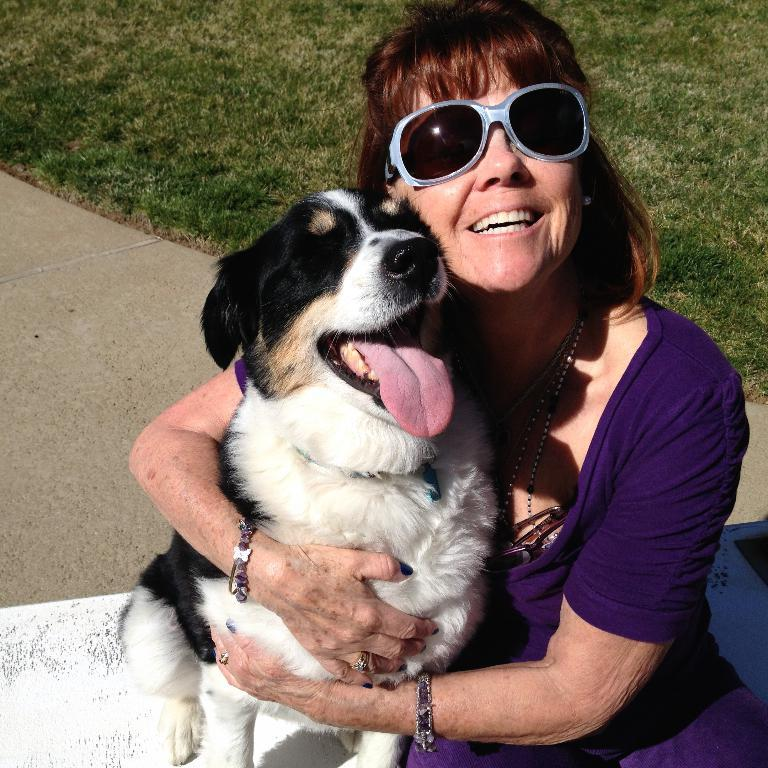What type of vegetation is present in the image? There is green grass in the image. Who is present in the image? There is a woman in the image. What is the woman wearing on her face? The woman is wearing goggles. What is the woman's facial expression? The woman is smiling. What is the woman holding in the image? The woman is holding a dog. What is the color of the dog? The dog is black and white in color. What type of advertisement can be seen in the image? There is no advertisement present in the image. What type of milk is the woman feeding to the dog in the image? There is no milk or feeding activity depicted in the image. 